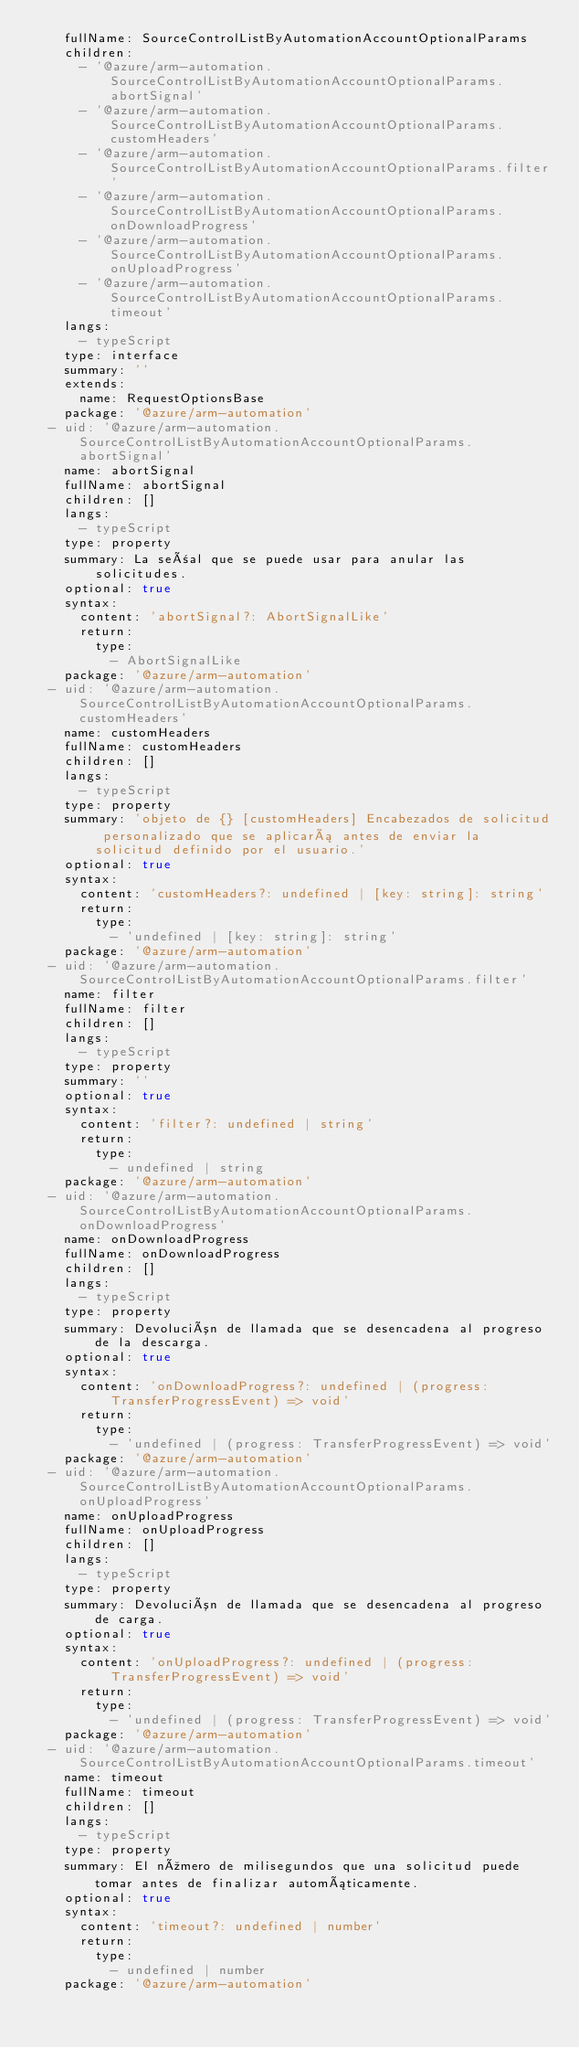<code> <loc_0><loc_0><loc_500><loc_500><_YAML_>    fullName: SourceControlListByAutomationAccountOptionalParams
    children:
      - '@azure/arm-automation.SourceControlListByAutomationAccountOptionalParams.abortSignal'
      - '@azure/arm-automation.SourceControlListByAutomationAccountOptionalParams.customHeaders'
      - '@azure/arm-automation.SourceControlListByAutomationAccountOptionalParams.filter'
      - '@azure/arm-automation.SourceControlListByAutomationAccountOptionalParams.onDownloadProgress'
      - '@azure/arm-automation.SourceControlListByAutomationAccountOptionalParams.onUploadProgress'
      - '@azure/arm-automation.SourceControlListByAutomationAccountOptionalParams.timeout'
    langs:
      - typeScript
    type: interface
    summary: ''
    extends:
      name: RequestOptionsBase
    package: '@azure/arm-automation'
  - uid: '@azure/arm-automation.SourceControlListByAutomationAccountOptionalParams.abortSignal'
    name: abortSignal
    fullName: abortSignal
    children: []
    langs:
      - typeScript
    type: property
    summary: La señal que se puede usar para anular las solicitudes.
    optional: true
    syntax:
      content: 'abortSignal?: AbortSignalLike'
      return:
        type:
          - AbortSignalLike
    package: '@azure/arm-automation'
  - uid: '@azure/arm-automation.SourceControlListByAutomationAccountOptionalParams.customHeaders'
    name: customHeaders
    fullName: customHeaders
    children: []
    langs:
      - typeScript
    type: property
    summary: 'objeto de {} [customHeaders] Encabezados de solicitud personalizado que se aplicará antes de enviar la solicitud definido por el usuario.'
    optional: true
    syntax:
      content: 'customHeaders?: undefined | [key: string]: string'
      return:
        type:
          - 'undefined | [key: string]: string'
    package: '@azure/arm-automation'
  - uid: '@azure/arm-automation.SourceControlListByAutomationAccountOptionalParams.filter'
    name: filter
    fullName: filter
    children: []
    langs:
      - typeScript
    type: property
    summary: ''
    optional: true
    syntax:
      content: 'filter?: undefined | string'
      return:
        type:
          - undefined | string
    package: '@azure/arm-automation'
  - uid: '@azure/arm-automation.SourceControlListByAutomationAccountOptionalParams.onDownloadProgress'
    name: onDownloadProgress
    fullName: onDownloadProgress
    children: []
    langs:
      - typeScript
    type: property
    summary: Devolución de llamada que se desencadena al progreso de la descarga.
    optional: true
    syntax:
      content: 'onDownloadProgress?: undefined | (progress: TransferProgressEvent) => void'
      return:
        type:
          - 'undefined | (progress: TransferProgressEvent) => void'
    package: '@azure/arm-automation'
  - uid: '@azure/arm-automation.SourceControlListByAutomationAccountOptionalParams.onUploadProgress'
    name: onUploadProgress
    fullName: onUploadProgress
    children: []
    langs:
      - typeScript
    type: property
    summary: Devolución de llamada que se desencadena al progreso de carga.
    optional: true
    syntax:
      content: 'onUploadProgress?: undefined | (progress: TransferProgressEvent) => void'
      return:
        type:
          - 'undefined | (progress: TransferProgressEvent) => void'
    package: '@azure/arm-automation'
  - uid: '@azure/arm-automation.SourceControlListByAutomationAccountOptionalParams.timeout'
    name: timeout
    fullName: timeout
    children: []
    langs:
      - typeScript
    type: property
    summary: El número de milisegundos que una solicitud puede tomar antes de finalizar automáticamente.
    optional: true
    syntax:
      content: 'timeout?: undefined | number'
      return:
        type:
          - undefined | number
    package: '@azure/arm-automation'</code> 